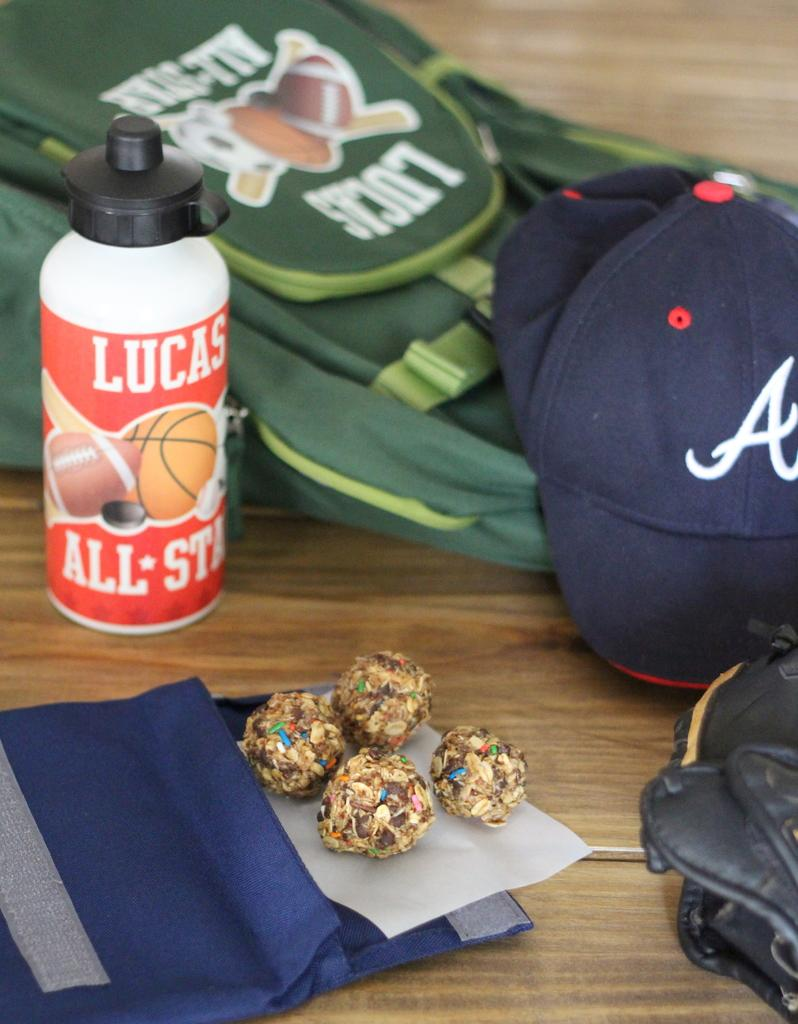What is one item visible in the image? There is a bag in the image. What is another item visible in the image? There is a bottle in the image. Where are these items located in the image? The items are on a table in the image. What type of loaf is being prepared on the table in the image? There is no loaf present in the image; it only features a bag and a bottle on a table. 